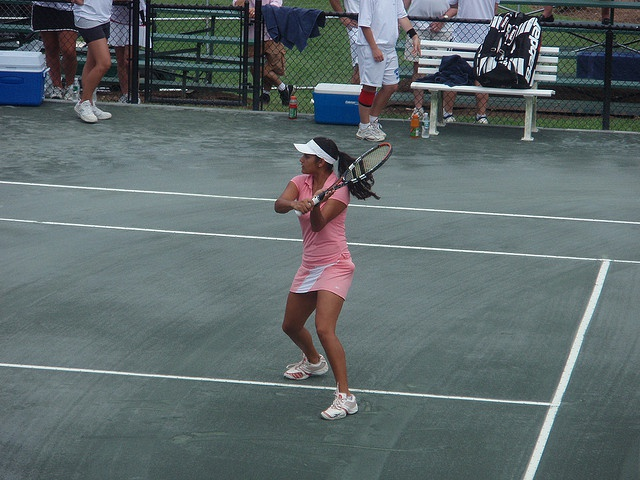Describe the objects in this image and their specific colors. I can see people in navy, brown, gray, maroon, and black tones, people in navy, darkgray, lightgray, and gray tones, bench in navy, lightgray, gray, darkgray, and black tones, backpack in navy, black, lightgray, darkgray, and gray tones, and people in navy, black, maroon, gray, and darkgray tones in this image. 